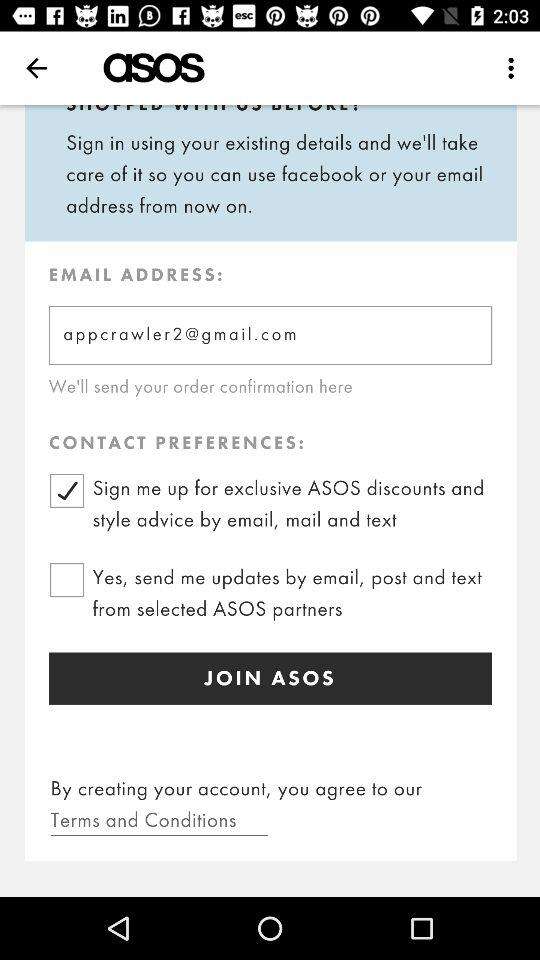Which option is selected for contact preferences? The selected option is "Sign me up for exclusive ASOS discounts and style advice by email, mail and text". 